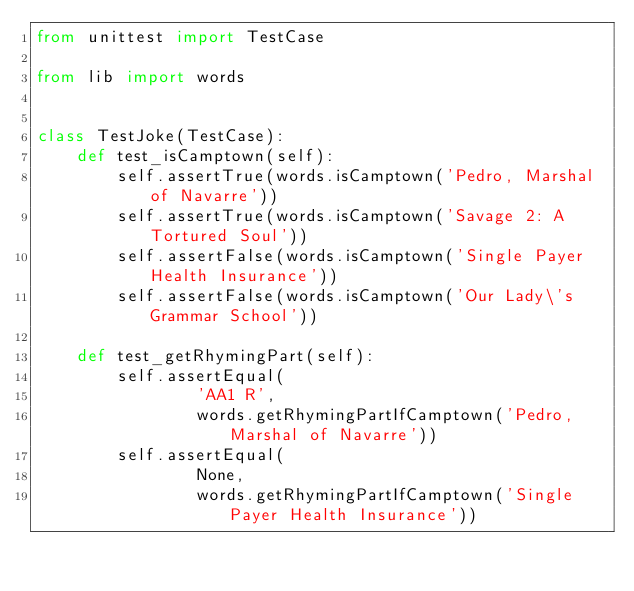Convert code to text. <code><loc_0><loc_0><loc_500><loc_500><_Python_>from unittest import TestCase

from lib import words


class TestJoke(TestCase):
    def test_isCamptown(self):
        self.assertTrue(words.isCamptown('Pedro, Marshal of Navarre'))
        self.assertTrue(words.isCamptown('Savage 2: A Tortured Soul'))
        self.assertFalse(words.isCamptown('Single Payer Health Insurance'))
        self.assertFalse(words.isCamptown('Our Lady\'s Grammar School'))

    def test_getRhymingPart(self):
        self.assertEqual(
                'AA1 R',
                words.getRhymingPartIfCamptown('Pedro, Marshal of Navarre'))
        self.assertEqual(
                None,
                words.getRhymingPartIfCamptown('Single Payer Health Insurance'))
</code> 